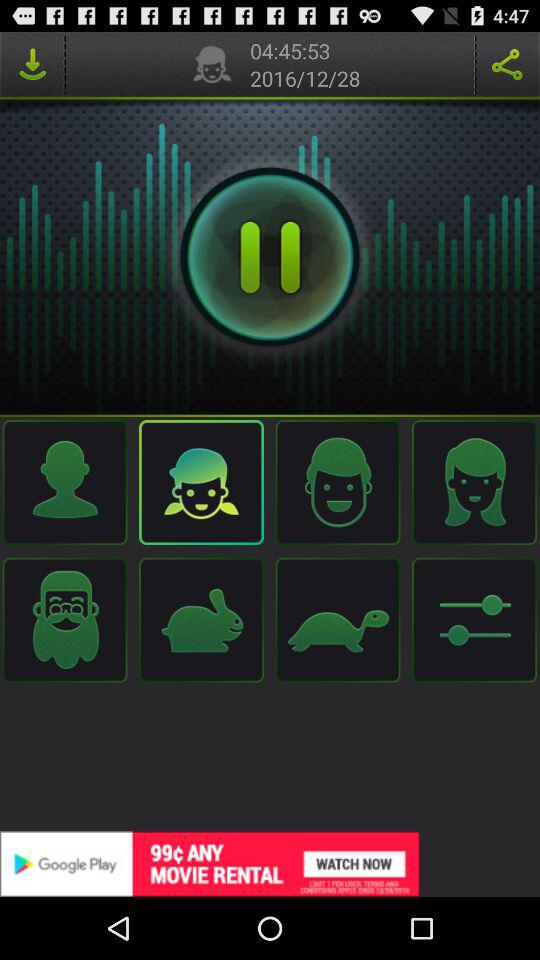What is the given date? The given date is December 28, 2016. 